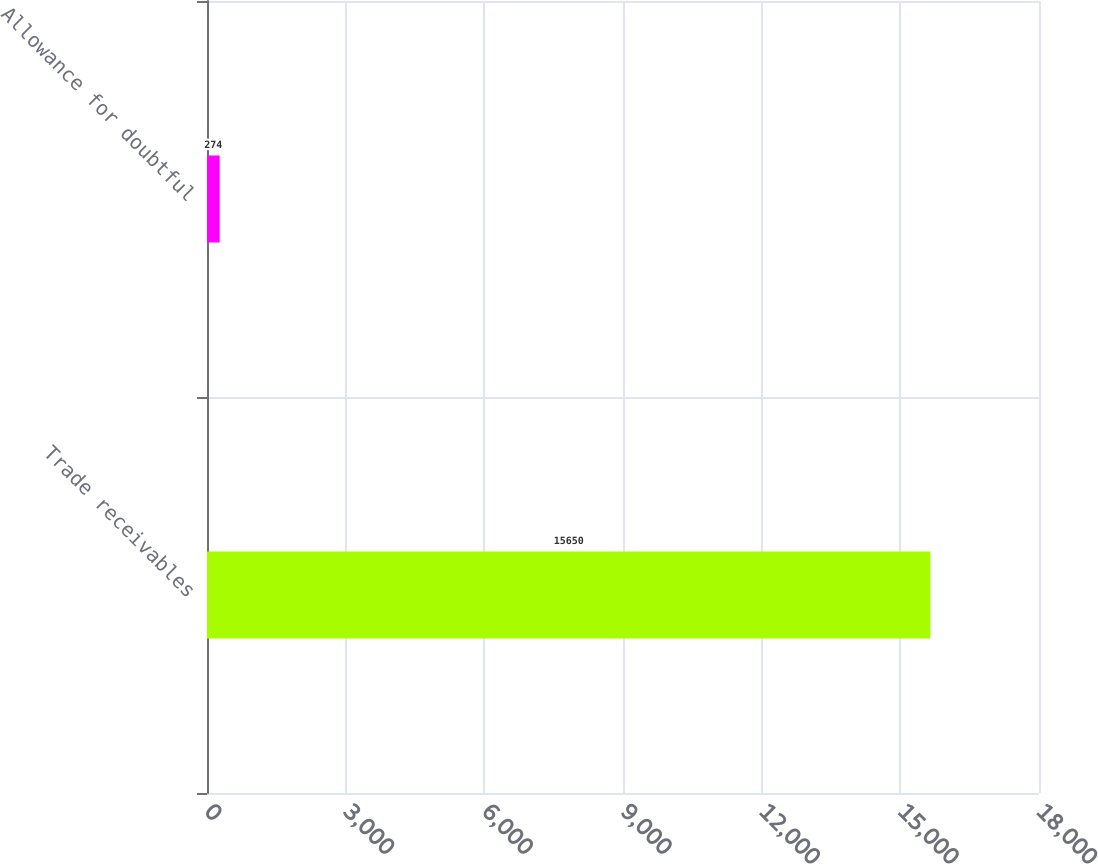Convert chart to OTSL. <chart><loc_0><loc_0><loc_500><loc_500><bar_chart><fcel>Trade receivables<fcel>Allowance for doubtful<nl><fcel>15650<fcel>274<nl></chart> 